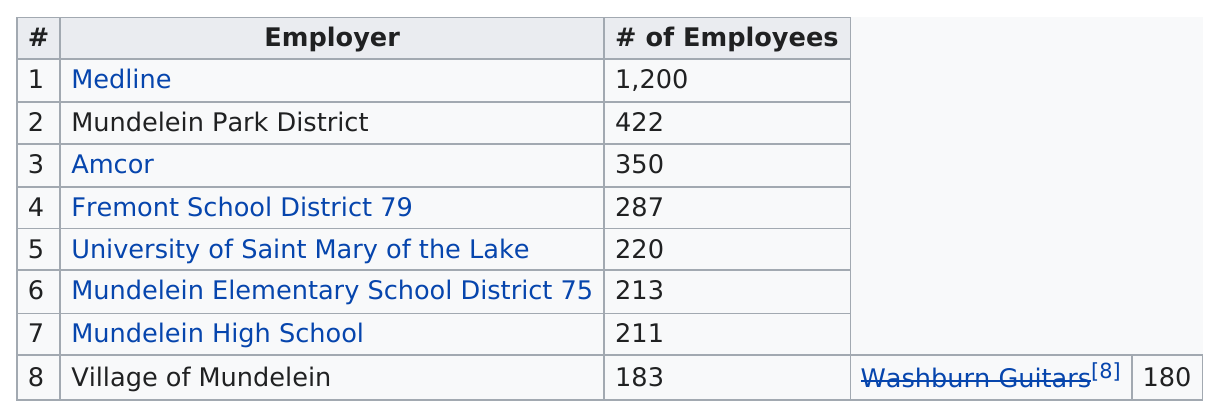Point out several critical features in this image. Of the employers with a maximum workforce of 375 or fewer employees, Amcor was one of them. The combined number of employees among the first three employers is 1,972. Medline is the employer with the largest number of employees. Medline is the employer with the most employees. The village of Mundelein has fewer employees than the Mundelein Elementary School District 75. 